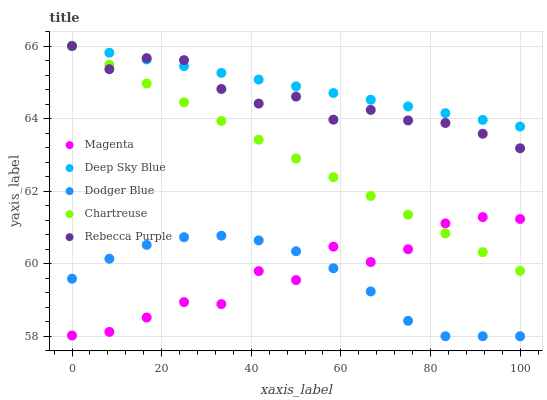Does Dodger Blue have the minimum area under the curve?
Answer yes or no. Yes. Does Deep Sky Blue have the maximum area under the curve?
Answer yes or no. Yes. Does Chartreuse have the minimum area under the curve?
Answer yes or no. No. Does Chartreuse have the maximum area under the curve?
Answer yes or no. No. Is Deep Sky Blue the smoothest?
Answer yes or no. Yes. Is Magenta the roughest?
Answer yes or no. Yes. Is Dodger Blue the smoothest?
Answer yes or no. No. Is Dodger Blue the roughest?
Answer yes or no. No. Does Dodger Blue have the lowest value?
Answer yes or no. Yes. Does Chartreuse have the lowest value?
Answer yes or no. No. Does Rebecca Purple have the highest value?
Answer yes or no. Yes. Does Dodger Blue have the highest value?
Answer yes or no. No. Is Dodger Blue less than Deep Sky Blue?
Answer yes or no. Yes. Is Chartreuse greater than Dodger Blue?
Answer yes or no. Yes. Does Rebecca Purple intersect Deep Sky Blue?
Answer yes or no. Yes. Is Rebecca Purple less than Deep Sky Blue?
Answer yes or no. No. Is Rebecca Purple greater than Deep Sky Blue?
Answer yes or no. No. Does Dodger Blue intersect Deep Sky Blue?
Answer yes or no. No. 